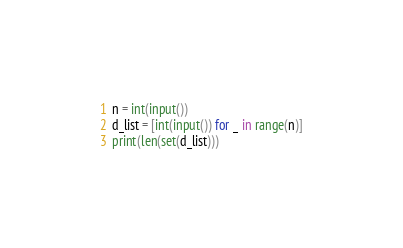Convert code to text. <code><loc_0><loc_0><loc_500><loc_500><_Python_>n = int(input())
d_list = [int(input()) for _ in range(n)]
print(len(set(d_list)))</code> 